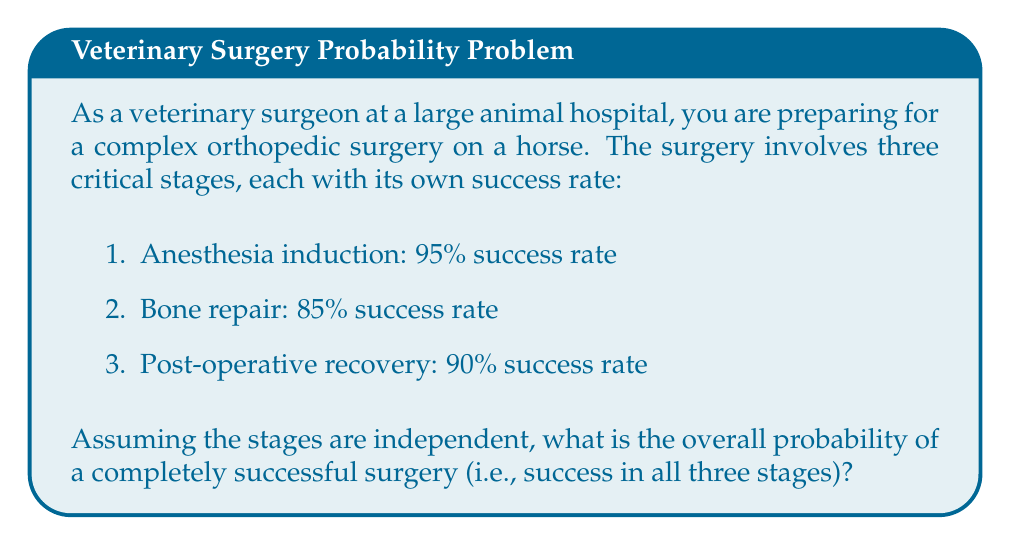What is the answer to this math problem? To solve this problem, we need to follow these steps:

1. Recognize that for the surgery to be completely successful, all three stages must be successful independently.

2. Since the events are independent, we can use the multiplication rule of probability. This states that the probability of multiple independent events occurring together is the product of their individual probabilities.

3. Let's define our events:
   A: Successful anesthesia induction
   B: Successful bone repair
   C: Successful post-operative recovery

4. We're looking for P(A ∩ B ∩ C), which equals P(A) × P(B) × P(C) for independent events.

5. Convert the given percentages to probabilities:
   P(A) = 95% = 0.95
   P(B) = 85% = 0.85
   P(C) = 90% = 0.90

6. Calculate the overall probability:

   $$P(\text{successful surgery}) = P(A) \times P(B) \times P(C)$$
   $$= 0.95 \times 0.85 \times 0.90$$
   $$= 0.72675$$

7. Convert the result to a percentage:
   0.72675 × 100% = 72.675%

Therefore, the overall probability of a completely successful surgery is approximately 72.68% (rounded to two decimal places).
Answer: 72.68% 